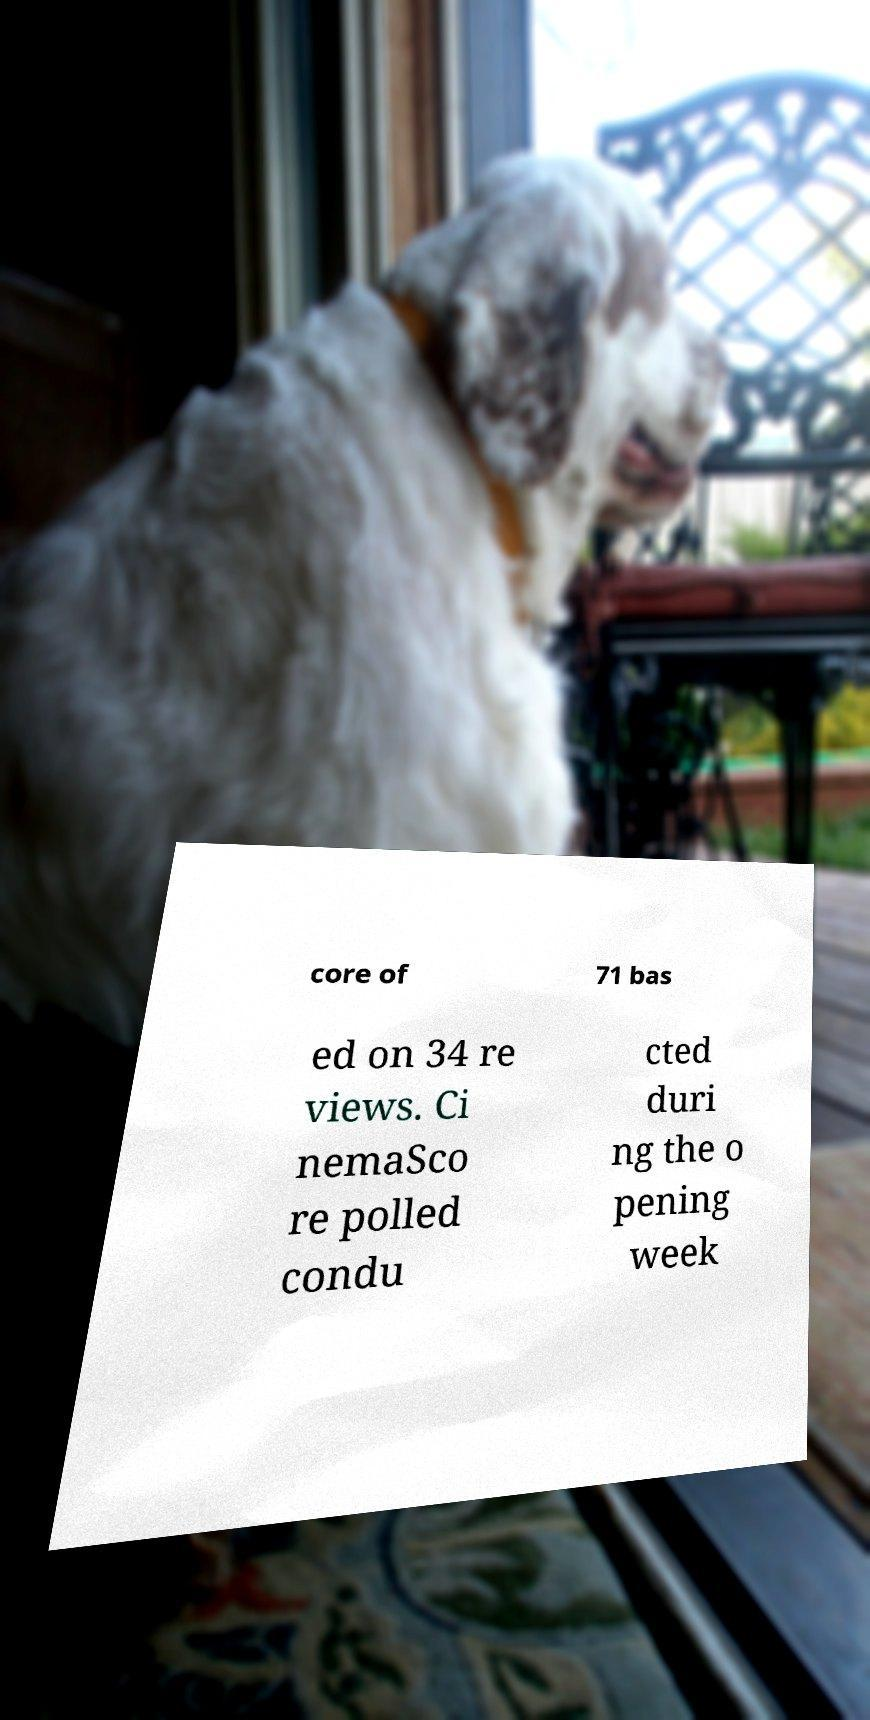For documentation purposes, I need the text within this image transcribed. Could you provide that? core of 71 bas ed on 34 re views. Ci nemaSco re polled condu cted duri ng the o pening week 